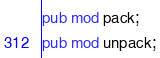Convert code to text. <code><loc_0><loc_0><loc_500><loc_500><_Rust_>pub mod pack;
pub mod unpack;
</code> 